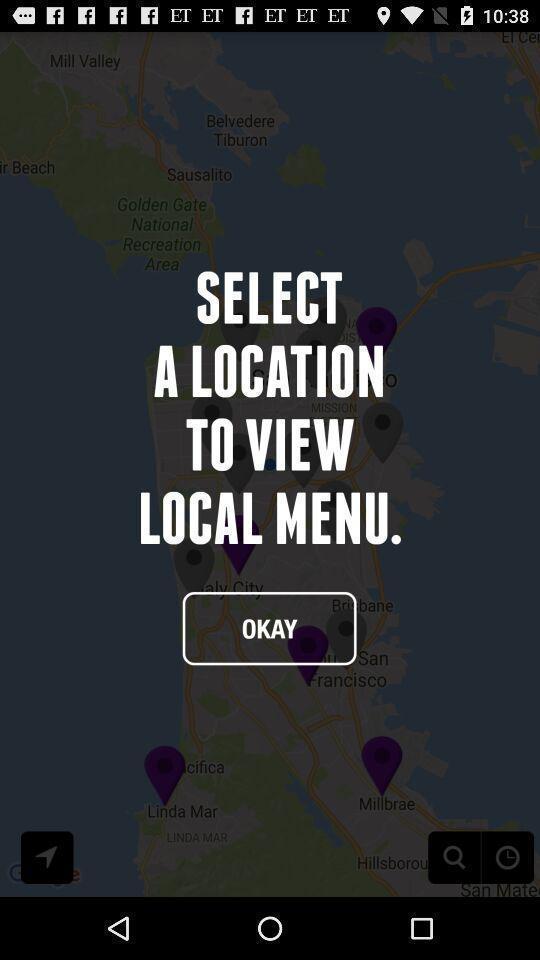Summarize the main components in this picture. Welcome page of the app. 